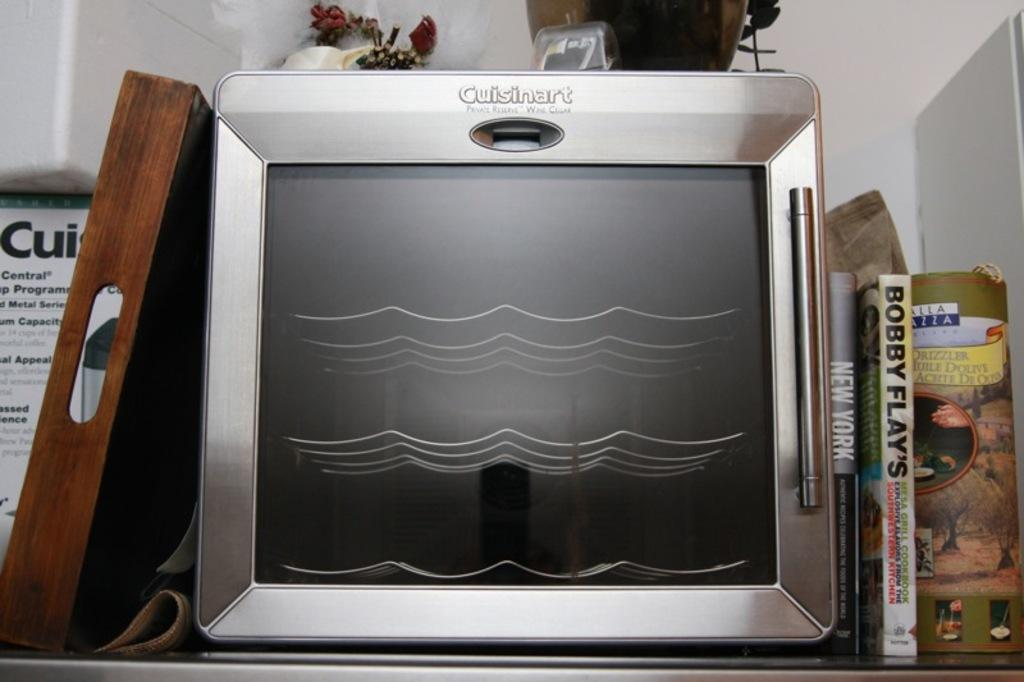Provide a one-sentence caption for the provided image. A Cuisinart oven is on a kitchen shelf next to Bobby Flay's cookbooks. 